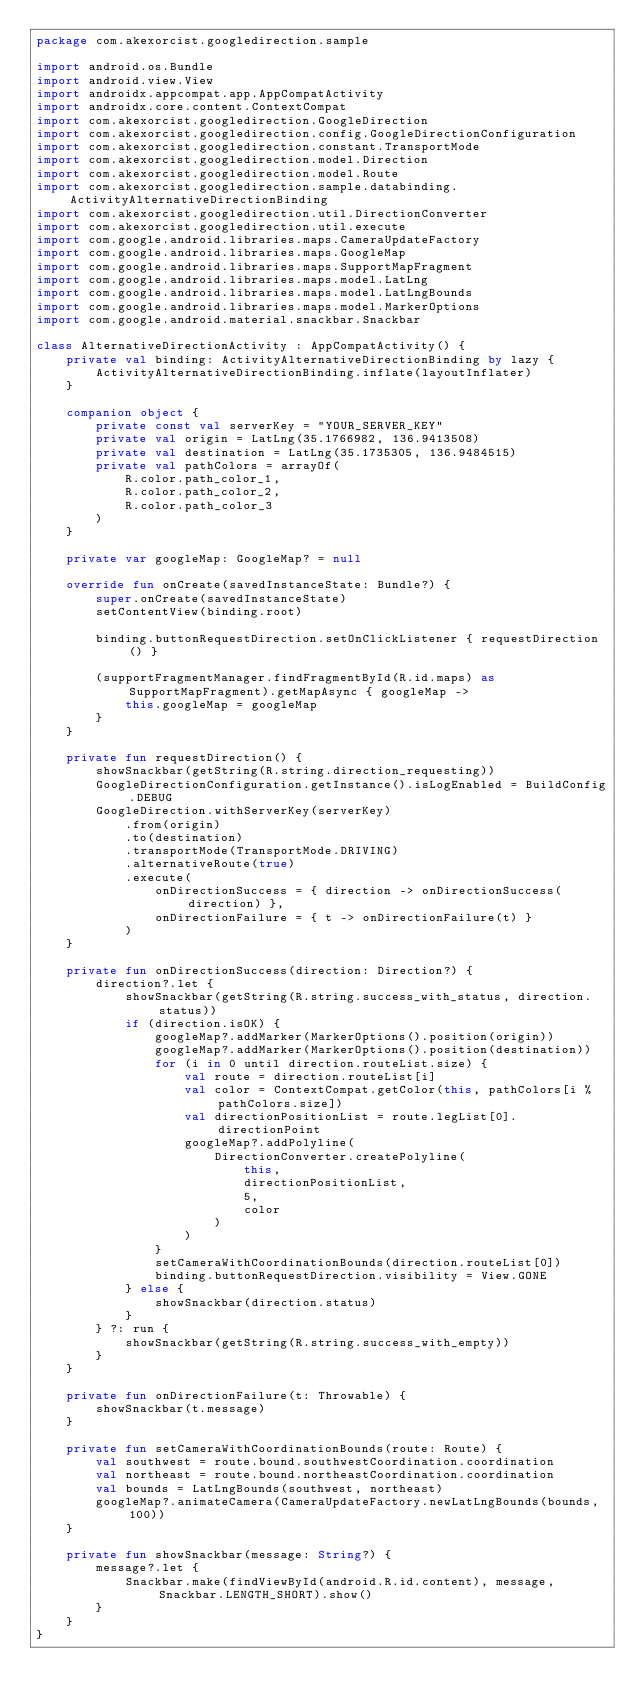Convert code to text. <code><loc_0><loc_0><loc_500><loc_500><_Kotlin_>package com.akexorcist.googledirection.sample

import android.os.Bundle
import android.view.View
import androidx.appcompat.app.AppCompatActivity
import androidx.core.content.ContextCompat
import com.akexorcist.googledirection.GoogleDirection
import com.akexorcist.googledirection.config.GoogleDirectionConfiguration
import com.akexorcist.googledirection.constant.TransportMode
import com.akexorcist.googledirection.model.Direction
import com.akexorcist.googledirection.model.Route
import com.akexorcist.googledirection.sample.databinding.ActivityAlternativeDirectionBinding
import com.akexorcist.googledirection.util.DirectionConverter
import com.akexorcist.googledirection.util.execute
import com.google.android.libraries.maps.CameraUpdateFactory
import com.google.android.libraries.maps.GoogleMap
import com.google.android.libraries.maps.SupportMapFragment
import com.google.android.libraries.maps.model.LatLng
import com.google.android.libraries.maps.model.LatLngBounds
import com.google.android.libraries.maps.model.MarkerOptions
import com.google.android.material.snackbar.Snackbar

class AlternativeDirectionActivity : AppCompatActivity() {
    private val binding: ActivityAlternativeDirectionBinding by lazy {
        ActivityAlternativeDirectionBinding.inflate(layoutInflater)
    }

    companion object {
        private const val serverKey = "YOUR_SERVER_KEY"
        private val origin = LatLng(35.1766982, 136.9413508)
        private val destination = LatLng(35.1735305, 136.9484515)
        private val pathColors = arrayOf(
            R.color.path_color_1,
            R.color.path_color_2,
            R.color.path_color_3
        )
    }

    private var googleMap: GoogleMap? = null

    override fun onCreate(savedInstanceState: Bundle?) {
        super.onCreate(savedInstanceState)
        setContentView(binding.root)

        binding.buttonRequestDirection.setOnClickListener { requestDirection() }

        (supportFragmentManager.findFragmentById(R.id.maps) as SupportMapFragment).getMapAsync { googleMap ->
            this.googleMap = googleMap
        }
    }

    private fun requestDirection() {
        showSnackbar(getString(R.string.direction_requesting))
        GoogleDirectionConfiguration.getInstance().isLogEnabled = BuildConfig.DEBUG
        GoogleDirection.withServerKey(serverKey)
            .from(origin)
            .to(destination)
            .transportMode(TransportMode.DRIVING)
            .alternativeRoute(true)
            .execute(
                onDirectionSuccess = { direction -> onDirectionSuccess(direction) },
                onDirectionFailure = { t -> onDirectionFailure(t) }
            )
    }

    private fun onDirectionSuccess(direction: Direction?) {
        direction?.let {
            showSnackbar(getString(R.string.success_with_status, direction.status))
            if (direction.isOK) {
                googleMap?.addMarker(MarkerOptions().position(origin))
                googleMap?.addMarker(MarkerOptions().position(destination))
                for (i in 0 until direction.routeList.size) {
                    val route = direction.routeList[i]
                    val color = ContextCompat.getColor(this, pathColors[i % pathColors.size])
                    val directionPositionList = route.legList[0].directionPoint
                    googleMap?.addPolyline(
                        DirectionConverter.createPolyline(
                            this,
                            directionPositionList,
                            5,
                            color
                        )
                    )
                }
                setCameraWithCoordinationBounds(direction.routeList[0])
                binding.buttonRequestDirection.visibility = View.GONE
            } else {
                showSnackbar(direction.status)
            }
        } ?: run {
            showSnackbar(getString(R.string.success_with_empty))
        }
    }

    private fun onDirectionFailure(t: Throwable) {
        showSnackbar(t.message)
    }

    private fun setCameraWithCoordinationBounds(route: Route) {
        val southwest = route.bound.southwestCoordination.coordination
        val northeast = route.bound.northeastCoordination.coordination
        val bounds = LatLngBounds(southwest, northeast)
        googleMap?.animateCamera(CameraUpdateFactory.newLatLngBounds(bounds, 100))
    }

    private fun showSnackbar(message: String?) {
        message?.let {
            Snackbar.make(findViewById(android.R.id.content), message, Snackbar.LENGTH_SHORT).show()
        }
    }
}
</code> 